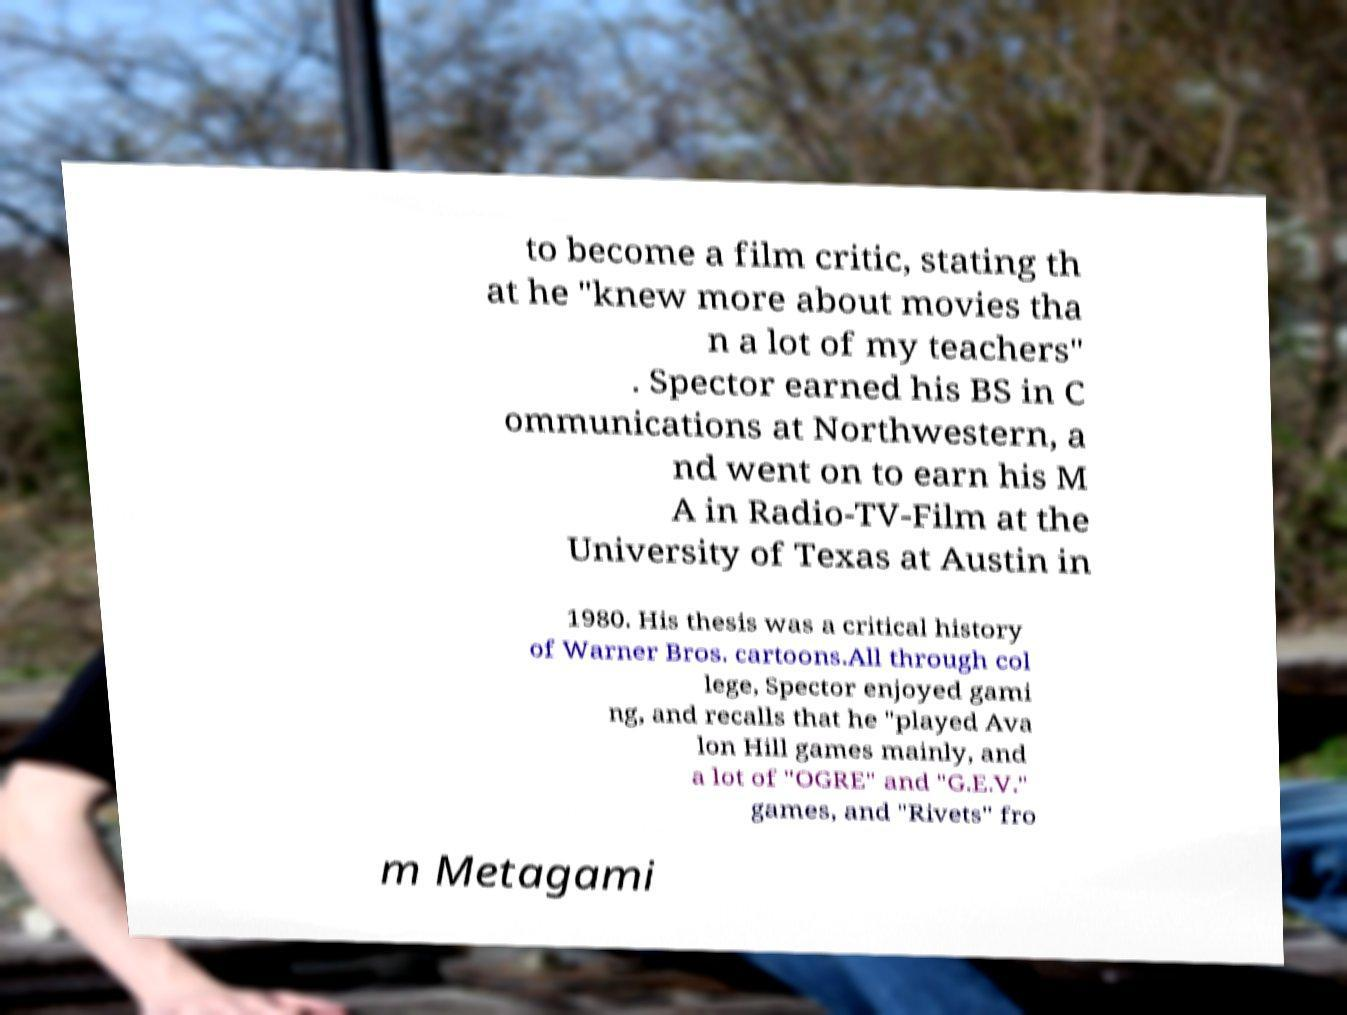For documentation purposes, I need the text within this image transcribed. Could you provide that? to become a film critic, stating th at he "knew more about movies tha n a lot of my teachers" . Spector earned his BS in C ommunications at Northwestern, a nd went on to earn his M A in Radio-TV-Film at the University of Texas at Austin in 1980. His thesis was a critical history of Warner Bros. cartoons.All through col lege, Spector enjoyed gami ng, and recalls that he "played Ava lon Hill games mainly, and a lot of "OGRE" and "G.E.V." games, and "Rivets" fro m Metagami 